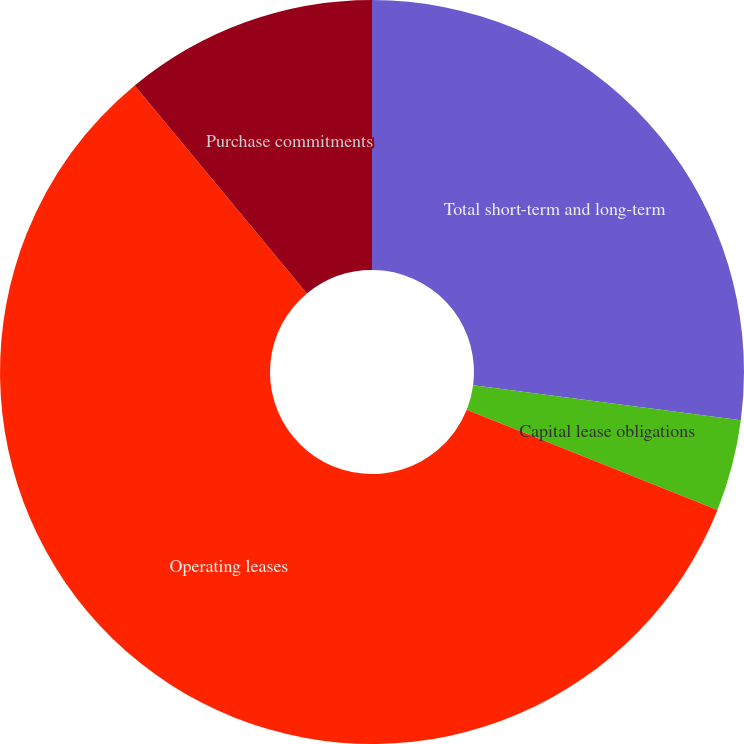<chart> <loc_0><loc_0><loc_500><loc_500><pie_chart><fcel>Total short-term and long-term<fcel>Capital lease obligations<fcel>Operating leases<fcel>Purchase commitments<nl><fcel>27.07%<fcel>3.97%<fcel>57.94%<fcel>11.01%<nl></chart> 